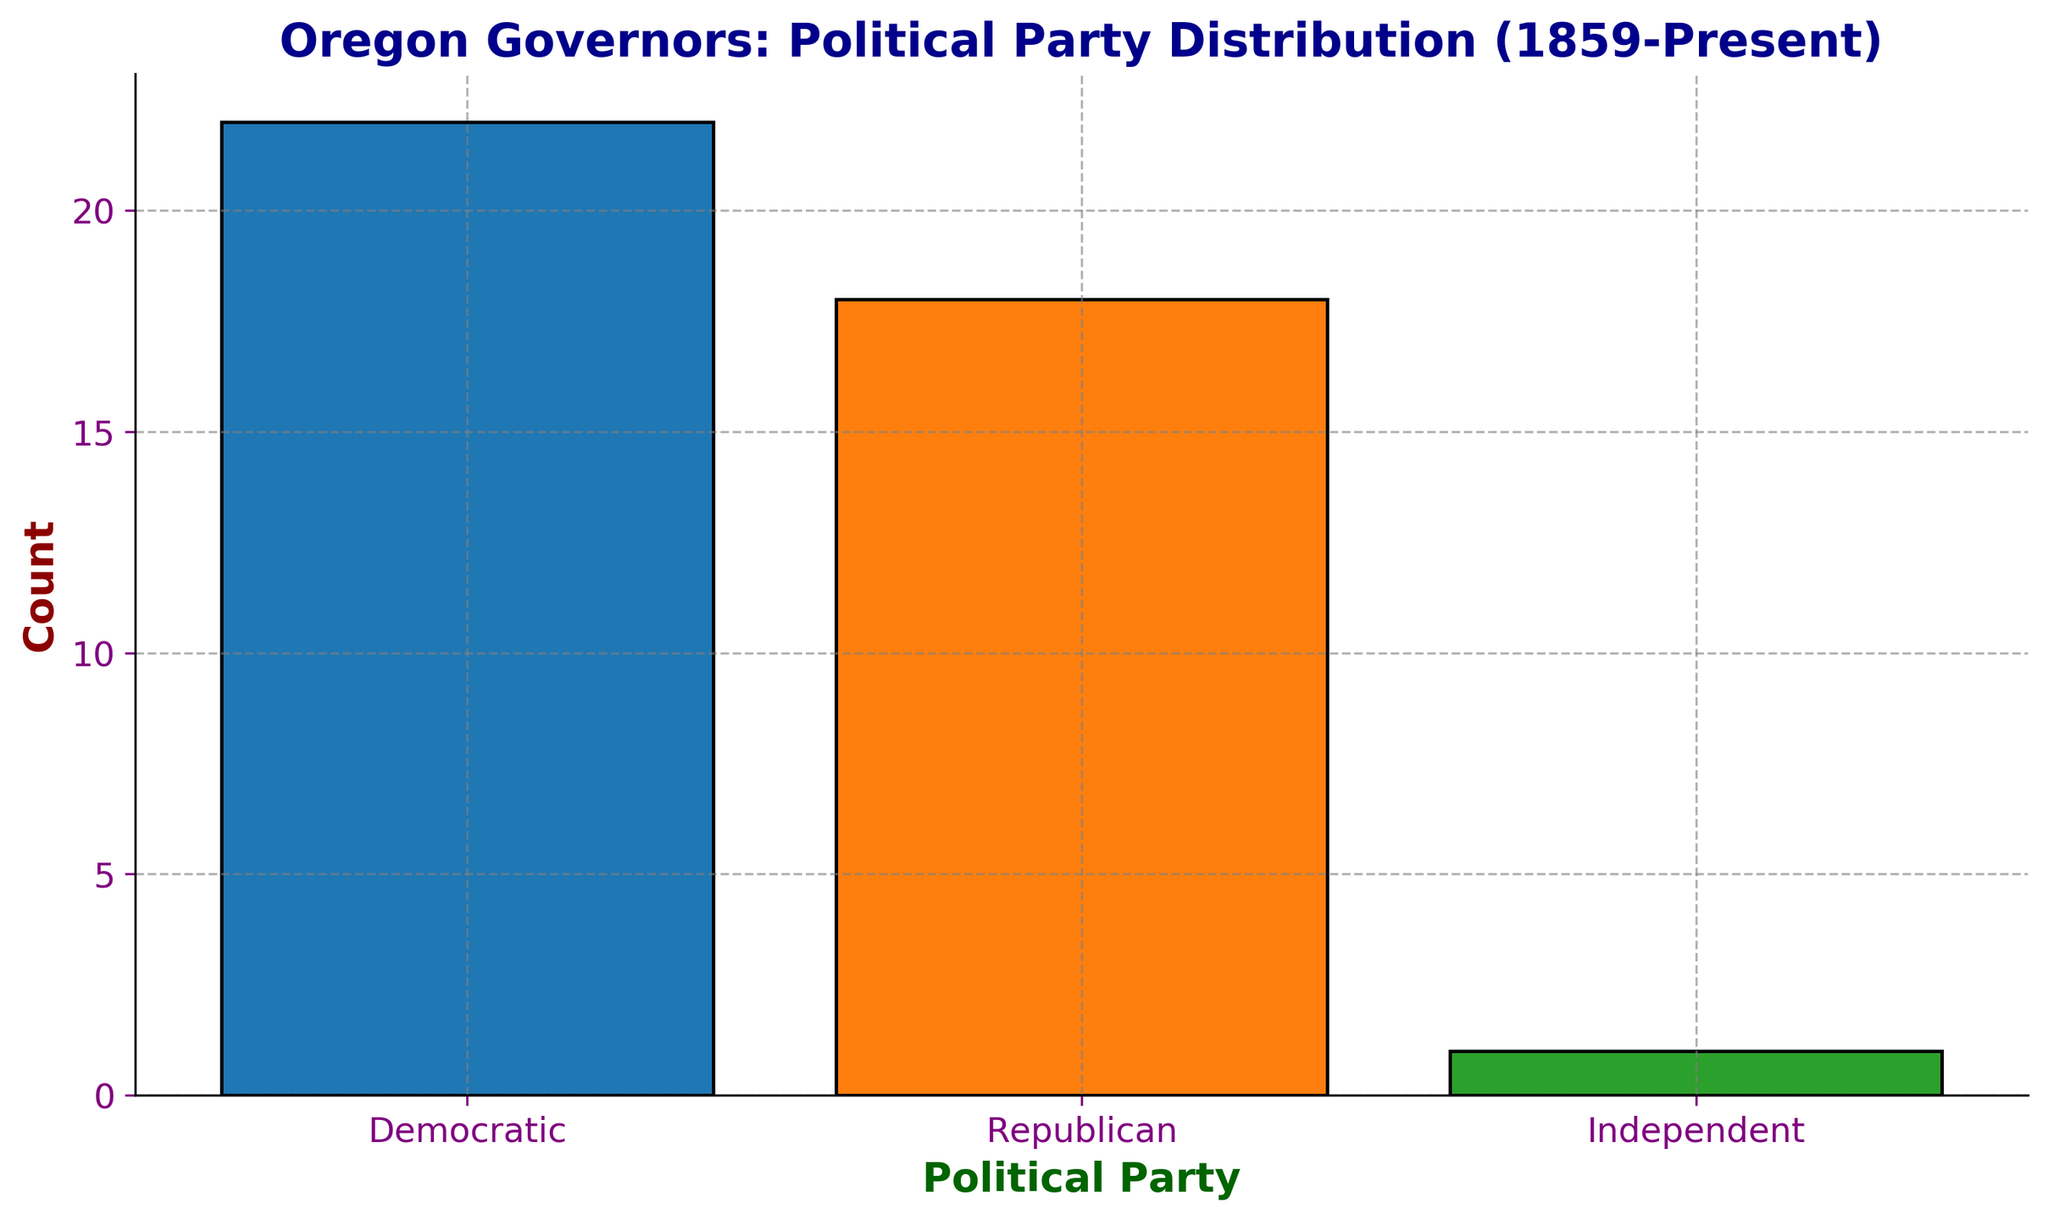What is the count of Democratic governors? The count for Democratic governors is represented by the height of the corresponding bar on the chart. It is labeled as 22.
Answer: 22 Which political party has the highest number of governors? By comparing the heights of the bars, the Democratic bar is the tallest. Therefore, the Democratic Party has the highest number of governors.
Answer: Democratic How many more Democratic governors are there compared to Republican governors? There are 22 Democratic governors and 18 Republican governors. The difference is calculated as 22 - 18.
Answer: 4 What is the total number of governors represented in the chart? To find the total, sum the counts of all political parties: 22 (Democratic) + 18 (Republican) + 1 (Independent). The total is 41.
Answer: 41 Which political party has the lowest representation among the governors? The bar for the Independent party has the lowest height, indicating they have the smallest count of just 1 governor.
Answer: Independent What percentage of the governors are from the Republican Party? Divide the count of Republican governors by the total number of governors and multiply by 100 to get the percentage: (18/41) * 100 ≈ 43.9%.
Answer: 43.9% How does the count of Independent governors compare to the combined total of Democratic and Republican governors? First, sum the counts of Democratic and Republican governors: 22 + 18 = 40. Then compare it to the count of Independent governors, which is 1. Since 1 is much less than 40, Independent governors form a very small proportion.
Answer: Independent governors are much less If you combined the Democratic and Independent governor counts, would it exceed the count of Republican governors? Combine the counts: 22 (Democratic) + 1 (Independent) = 23. Compare this to the Republican count of 18. Since 23 is greater than 18, the combined count exceeds the Republican count.
Answer: Yes What is the average number of governors per political party? Add the counts for all parties and divide by the number of parties: (22 + 18 + 1)/3. The average is (41/3) ≈ 13.67.
Answer: 13.67 How many more total Democratic and Republican governors are there compared to the total number of Independent governors? Combine the counts for Democratic and Republican governors: 22 + 18 = 40. Subtract the count of Independent governors (1) from this total: 40 - 1.
Answer: 39 